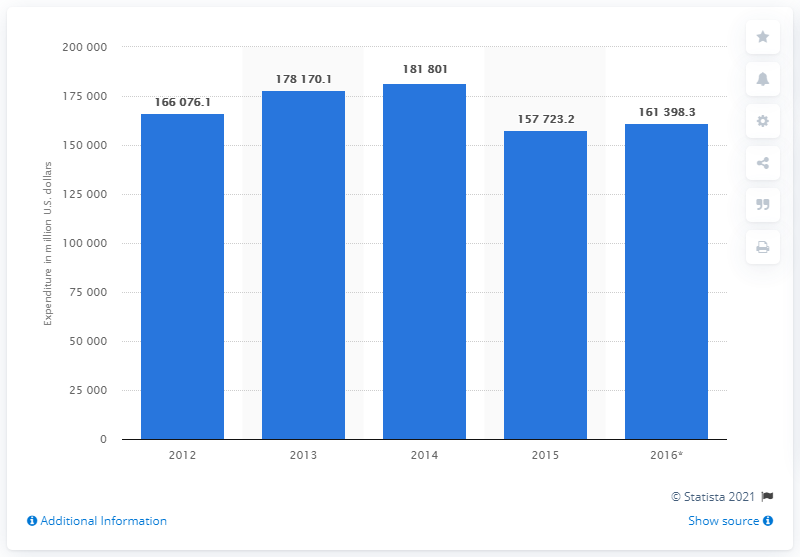Outline some significant characteristics in this image. The estimated expenditure on food in 2016 is projected to be 161,398.3. 